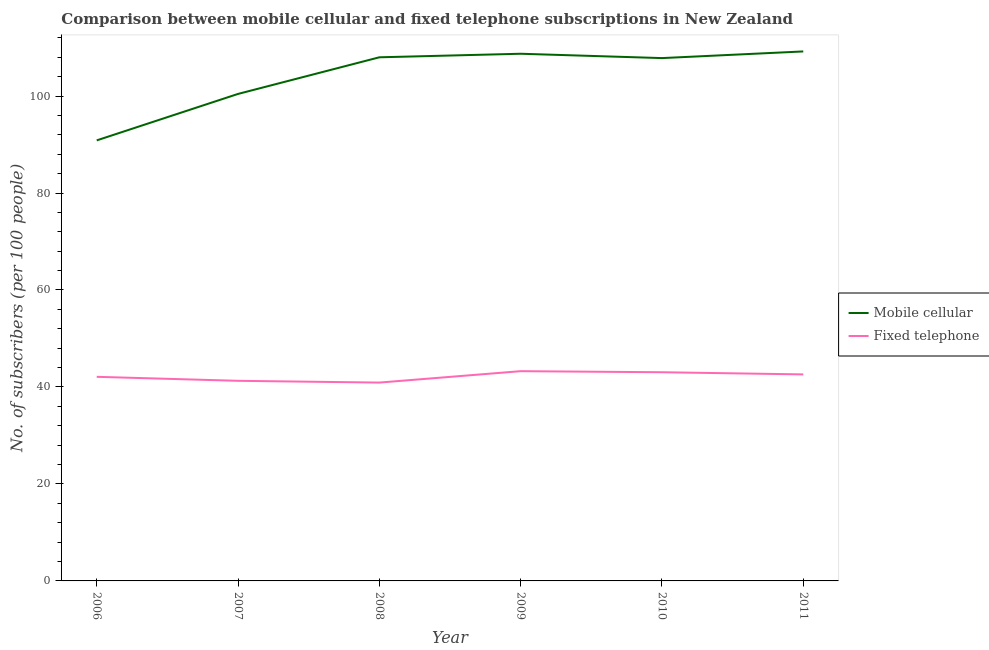How many different coloured lines are there?
Your answer should be very brief. 2. Does the line corresponding to number of fixed telephone subscribers intersect with the line corresponding to number of mobile cellular subscribers?
Your answer should be compact. No. Is the number of lines equal to the number of legend labels?
Offer a terse response. Yes. What is the number of fixed telephone subscribers in 2009?
Your answer should be compact. 43.26. Across all years, what is the maximum number of mobile cellular subscribers?
Give a very brief answer. 109.2. Across all years, what is the minimum number of mobile cellular subscribers?
Your response must be concise. 90.85. In which year was the number of mobile cellular subscribers minimum?
Provide a succinct answer. 2006. What is the total number of mobile cellular subscribers in the graph?
Your answer should be compact. 625.03. What is the difference between the number of fixed telephone subscribers in 2006 and that in 2011?
Give a very brief answer. -0.5. What is the difference between the number of fixed telephone subscribers in 2011 and the number of mobile cellular subscribers in 2009?
Ensure brevity in your answer.  -66.13. What is the average number of fixed telephone subscribers per year?
Make the answer very short. 42.19. In the year 2010, what is the difference between the number of fixed telephone subscribers and number of mobile cellular subscribers?
Make the answer very short. -64.79. In how many years, is the number of fixed telephone subscribers greater than 76?
Your answer should be compact. 0. What is the ratio of the number of fixed telephone subscribers in 2009 to that in 2010?
Your answer should be very brief. 1.01. What is the difference between the highest and the second highest number of fixed telephone subscribers?
Provide a succinct answer. 0.22. What is the difference between the highest and the lowest number of fixed telephone subscribers?
Offer a very short reply. 2.35. Is the sum of the number of mobile cellular subscribers in 2006 and 2007 greater than the maximum number of fixed telephone subscribers across all years?
Your response must be concise. Yes. Does the number of mobile cellular subscribers monotonically increase over the years?
Your response must be concise. No. How many lines are there?
Offer a very short reply. 2. Does the graph contain grids?
Your answer should be very brief. No. Where does the legend appear in the graph?
Make the answer very short. Center right. How many legend labels are there?
Your answer should be very brief. 2. What is the title of the graph?
Make the answer very short. Comparison between mobile cellular and fixed telephone subscriptions in New Zealand. Does "Rural Population" appear as one of the legend labels in the graph?
Offer a very short reply. No. What is the label or title of the X-axis?
Your answer should be very brief. Year. What is the label or title of the Y-axis?
Keep it short and to the point. No. of subscribers (per 100 people). What is the No. of subscribers (per 100 people) of Mobile cellular in 2006?
Offer a terse response. 90.85. What is the No. of subscribers (per 100 people) of Fixed telephone in 2006?
Your answer should be very brief. 42.09. What is the No. of subscribers (per 100 people) in Mobile cellular in 2007?
Provide a succinct answer. 100.44. What is the No. of subscribers (per 100 people) of Fixed telephone in 2007?
Your answer should be compact. 41.27. What is the No. of subscribers (per 100 people) in Mobile cellular in 2008?
Provide a succinct answer. 107.99. What is the No. of subscribers (per 100 people) of Fixed telephone in 2008?
Your answer should be compact. 40.91. What is the No. of subscribers (per 100 people) in Mobile cellular in 2009?
Give a very brief answer. 108.72. What is the No. of subscribers (per 100 people) of Fixed telephone in 2009?
Offer a terse response. 43.26. What is the No. of subscribers (per 100 people) in Mobile cellular in 2010?
Keep it short and to the point. 107.83. What is the No. of subscribers (per 100 people) in Fixed telephone in 2010?
Keep it short and to the point. 43.04. What is the No. of subscribers (per 100 people) of Mobile cellular in 2011?
Offer a very short reply. 109.2. What is the No. of subscribers (per 100 people) in Fixed telephone in 2011?
Provide a succinct answer. 42.59. Across all years, what is the maximum No. of subscribers (per 100 people) of Mobile cellular?
Your answer should be very brief. 109.2. Across all years, what is the maximum No. of subscribers (per 100 people) of Fixed telephone?
Your response must be concise. 43.26. Across all years, what is the minimum No. of subscribers (per 100 people) of Mobile cellular?
Ensure brevity in your answer.  90.85. Across all years, what is the minimum No. of subscribers (per 100 people) of Fixed telephone?
Offer a terse response. 40.91. What is the total No. of subscribers (per 100 people) in Mobile cellular in the graph?
Provide a short and direct response. 625.03. What is the total No. of subscribers (per 100 people) of Fixed telephone in the graph?
Keep it short and to the point. 253.16. What is the difference between the No. of subscribers (per 100 people) in Mobile cellular in 2006 and that in 2007?
Offer a very short reply. -9.58. What is the difference between the No. of subscribers (per 100 people) of Fixed telephone in 2006 and that in 2007?
Make the answer very short. 0.82. What is the difference between the No. of subscribers (per 100 people) in Mobile cellular in 2006 and that in 2008?
Give a very brief answer. -17.13. What is the difference between the No. of subscribers (per 100 people) in Fixed telephone in 2006 and that in 2008?
Your response must be concise. 1.19. What is the difference between the No. of subscribers (per 100 people) of Mobile cellular in 2006 and that in 2009?
Provide a succinct answer. -17.87. What is the difference between the No. of subscribers (per 100 people) of Fixed telephone in 2006 and that in 2009?
Give a very brief answer. -1.16. What is the difference between the No. of subscribers (per 100 people) in Mobile cellular in 2006 and that in 2010?
Keep it short and to the point. -16.97. What is the difference between the No. of subscribers (per 100 people) in Fixed telephone in 2006 and that in 2010?
Keep it short and to the point. -0.94. What is the difference between the No. of subscribers (per 100 people) in Mobile cellular in 2006 and that in 2011?
Your answer should be very brief. -18.35. What is the difference between the No. of subscribers (per 100 people) in Fixed telephone in 2006 and that in 2011?
Ensure brevity in your answer.  -0.5. What is the difference between the No. of subscribers (per 100 people) of Mobile cellular in 2007 and that in 2008?
Offer a terse response. -7.55. What is the difference between the No. of subscribers (per 100 people) of Fixed telephone in 2007 and that in 2008?
Keep it short and to the point. 0.37. What is the difference between the No. of subscribers (per 100 people) of Mobile cellular in 2007 and that in 2009?
Your answer should be very brief. -8.29. What is the difference between the No. of subscribers (per 100 people) of Fixed telephone in 2007 and that in 2009?
Make the answer very short. -1.99. What is the difference between the No. of subscribers (per 100 people) in Mobile cellular in 2007 and that in 2010?
Offer a terse response. -7.39. What is the difference between the No. of subscribers (per 100 people) of Fixed telephone in 2007 and that in 2010?
Provide a succinct answer. -1.77. What is the difference between the No. of subscribers (per 100 people) of Mobile cellular in 2007 and that in 2011?
Offer a terse response. -8.76. What is the difference between the No. of subscribers (per 100 people) of Fixed telephone in 2007 and that in 2011?
Provide a succinct answer. -1.32. What is the difference between the No. of subscribers (per 100 people) of Mobile cellular in 2008 and that in 2009?
Your answer should be compact. -0.73. What is the difference between the No. of subscribers (per 100 people) in Fixed telephone in 2008 and that in 2009?
Your response must be concise. -2.35. What is the difference between the No. of subscribers (per 100 people) in Mobile cellular in 2008 and that in 2010?
Offer a terse response. 0.16. What is the difference between the No. of subscribers (per 100 people) in Fixed telephone in 2008 and that in 2010?
Give a very brief answer. -2.13. What is the difference between the No. of subscribers (per 100 people) of Mobile cellular in 2008 and that in 2011?
Provide a short and direct response. -1.21. What is the difference between the No. of subscribers (per 100 people) in Fixed telephone in 2008 and that in 2011?
Your answer should be compact. -1.69. What is the difference between the No. of subscribers (per 100 people) in Mobile cellular in 2009 and that in 2010?
Your answer should be compact. 0.9. What is the difference between the No. of subscribers (per 100 people) of Fixed telephone in 2009 and that in 2010?
Offer a very short reply. 0.22. What is the difference between the No. of subscribers (per 100 people) of Mobile cellular in 2009 and that in 2011?
Offer a very short reply. -0.48. What is the difference between the No. of subscribers (per 100 people) in Fixed telephone in 2009 and that in 2011?
Your response must be concise. 0.67. What is the difference between the No. of subscribers (per 100 people) in Mobile cellular in 2010 and that in 2011?
Give a very brief answer. -1.37. What is the difference between the No. of subscribers (per 100 people) in Fixed telephone in 2010 and that in 2011?
Offer a very short reply. 0.45. What is the difference between the No. of subscribers (per 100 people) in Mobile cellular in 2006 and the No. of subscribers (per 100 people) in Fixed telephone in 2007?
Your answer should be very brief. 49.58. What is the difference between the No. of subscribers (per 100 people) of Mobile cellular in 2006 and the No. of subscribers (per 100 people) of Fixed telephone in 2008?
Ensure brevity in your answer.  49.95. What is the difference between the No. of subscribers (per 100 people) of Mobile cellular in 2006 and the No. of subscribers (per 100 people) of Fixed telephone in 2009?
Make the answer very short. 47.6. What is the difference between the No. of subscribers (per 100 people) in Mobile cellular in 2006 and the No. of subscribers (per 100 people) in Fixed telephone in 2010?
Offer a terse response. 47.82. What is the difference between the No. of subscribers (per 100 people) of Mobile cellular in 2006 and the No. of subscribers (per 100 people) of Fixed telephone in 2011?
Ensure brevity in your answer.  48.26. What is the difference between the No. of subscribers (per 100 people) in Mobile cellular in 2007 and the No. of subscribers (per 100 people) in Fixed telephone in 2008?
Offer a terse response. 59.53. What is the difference between the No. of subscribers (per 100 people) in Mobile cellular in 2007 and the No. of subscribers (per 100 people) in Fixed telephone in 2009?
Your response must be concise. 57.18. What is the difference between the No. of subscribers (per 100 people) in Mobile cellular in 2007 and the No. of subscribers (per 100 people) in Fixed telephone in 2010?
Make the answer very short. 57.4. What is the difference between the No. of subscribers (per 100 people) of Mobile cellular in 2007 and the No. of subscribers (per 100 people) of Fixed telephone in 2011?
Give a very brief answer. 57.84. What is the difference between the No. of subscribers (per 100 people) of Mobile cellular in 2008 and the No. of subscribers (per 100 people) of Fixed telephone in 2009?
Provide a succinct answer. 64.73. What is the difference between the No. of subscribers (per 100 people) of Mobile cellular in 2008 and the No. of subscribers (per 100 people) of Fixed telephone in 2010?
Your response must be concise. 64.95. What is the difference between the No. of subscribers (per 100 people) in Mobile cellular in 2008 and the No. of subscribers (per 100 people) in Fixed telephone in 2011?
Provide a short and direct response. 65.4. What is the difference between the No. of subscribers (per 100 people) of Mobile cellular in 2009 and the No. of subscribers (per 100 people) of Fixed telephone in 2010?
Offer a very short reply. 65.68. What is the difference between the No. of subscribers (per 100 people) of Mobile cellular in 2009 and the No. of subscribers (per 100 people) of Fixed telephone in 2011?
Give a very brief answer. 66.13. What is the difference between the No. of subscribers (per 100 people) of Mobile cellular in 2010 and the No. of subscribers (per 100 people) of Fixed telephone in 2011?
Make the answer very short. 65.23. What is the average No. of subscribers (per 100 people) in Mobile cellular per year?
Keep it short and to the point. 104.17. What is the average No. of subscribers (per 100 people) of Fixed telephone per year?
Make the answer very short. 42.19. In the year 2006, what is the difference between the No. of subscribers (per 100 people) of Mobile cellular and No. of subscribers (per 100 people) of Fixed telephone?
Ensure brevity in your answer.  48.76. In the year 2007, what is the difference between the No. of subscribers (per 100 people) of Mobile cellular and No. of subscribers (per 100 people) of Fixed telephone?
Offer a terse response. 59.17. In the year 2008, what is the difference between the No. of subscribers (per 100 people) of Mobile cellular and No. of subscribers (per 100 people) of Fixed telephone?
Keep it short and to the point. 67.08. In the year 2009, what is the difference between the No. of subscribers (per 100 people) of Mobile cellular and No. of subscribers (per 100 people) of Fixed telephone?
Offer a very short reply. 65.46. In the year 2010, what is the difference between the No. of subscribers (per 100 people) of Mobile cellular and No. of subscribers (per 100 people) of Fixed telephone?
Provide a short and direct response. 64.79. In the year 2011, what is the difference between the No. of subscribers (per 100 people) of Mobile cellular and No. of subscribers (per 100 people) of Fixed telephone?
Keep it short and to the point. 66.61. What is the ratio of the No. of subscribers (per 100 people) of Mobile cellular in 2006 to that in 2007?
Keep it short and to the point. 0.9. What is the ratio of the No. of subscribers (per 100 people) of Mobile cellular in 2006 to that in 2008?
Your answer should be very brief. 0.84. What is the ratio of the No. of subscribers (per 100 people) of Fixed telephone in 2006 to that in 2008?
Give a very brief answer. 1.03. What is the ratio of the No. of subscribers (per 100 people) of Mobile cellular in 2006 to that in 2009?
Your answer should be very brief. 0.84. What is the ratio of the No. of subscribers (per 100 people) in Fixed telephone in 2006 to that in 2009?
Make the answer very short. 0.97. What is the ratio of the No. of subscribers (per 100 people) of Mobile cellular in 2006 to that in 2010?
Offer a very short reply. 0.84. What is the ratio of the No. of subscribers (per 100 people) in Fixed telephone in 2006 to that in 2010?
Make the answer very short. 0.98. What is the ratio of the No. of subscribers (per 100 people) of Mobile cellular in 2006 to that in 2011?
Keep it short and to the point. 0.83. What is the ratio of the No. of subscribers (per 100 people) of Fixed telephone in 2006 to that in 2011?
Keep it short and to the point. 0.99. What is the ratio of the No. of subscribers (per 100 people) in Mobile cellular in 2007 to that in 2008?
Give a very brief answer. 0.93. What is the ratio of the No. of subscribers (per 100 people) in Fixed telephone in 2007 to that in 2008?
Your answer should be compact. 1.01. What is the ratio of the No. of subscribers (per 100 people) in Mobile cellular in 2007 to that in 2009?
Give a very brief answer. 0.92. What is the ratio of the No. of subscribers (per 100 people) in Fixed telephone in 2007 to that in 2009?
Ensure brevity in your answer.  0.95. What is the ratio of the No. of subscribers (per 100 people) in Mobile cellular in 2007 to that in 2010?
Offer a terse response. 0.93. What is the ratio of the No. of subscribers (per 100 people) of Fixed telephone in 2007 to that in 2010?
Offer a terse response. 0.96. What is the ratio of the No. of subscribers (per 100 people) in Mobile cellular in 2007 to that in 2011?
Make the answer very short. 0.92. What is the ratio of the No. of subscribers (per 100 people) in Fixed telephone in 2007 to that in 2011?
Offer a very short reply. 0.97. What is the ratio of the No. of subscribers (per 100 people) of Mobile cellular in 2008 to that in 2009?
Make the answer very short. 0.99. What is the ratio of the No. of subscribers (per 100 people) in Fixed telephone in 2008 to that in 2009?
Offer a very short reply. 0.95. What is the ratio of the No. of subscribers (per 100 people) of Mobile cellular in 2008 to that in 2010?
Give a very brief answer. 1. What is the ratio of the No. of subscribers (per 100 people) in Fixed telephone in 2008 to that in 2010?
Offer a very short reply. 0.95. What is the ratio of the No. of subscribers (per 100 people) in Mobile cellular in 2008 to that in 2011?
Offer a terse response. 0.99. What is the ratio of the No. of subscribers (per 100 people) in Fixed telephone in 2008 to that in 2011?
Ensure brevity in your answer.  0.96. What is the ratio of the No. of subscribers (per 100 people) in Mobile cellular in 2009 to that in 2010?
Keep it short and to the point. 1.01. What is the ratio of the No. of subscribers (per 100 people) in Mobile cellular in 2009 to that in 2011?
Offer a terse response. 1. What is the ratio of the No. of subscribers (per 100 people) of Fixed telephone in 2009 to that in 2011?
Give a very brief answer. 1.02. What is the ratio of the No. of subscribers (per 100 people) in Mobile cellular in 2010 to that in 2011?
Provide a succinct answer. 0.99. What is the ratio of the No. of subscribers (per 100 people) in Fixed telephone in 2010 to that in 2011?
Offer a terse response. 1.01. What is the difference between the highest and the second highest No. of subscribers (per 100 people) of Mobile cellular?
Provide a succinct answer. 0.48. What is the difference between the highest and the second highest No. of subscribers (per 100 people) of Fixed telephone?
Provide a short and direct response. 0.22. What is the difference between the highest and the lowest No. of subscribers (per 100 people) of Mobile cellular?
Your response must be concise. 18.35. What is the difference between the highest and the lowest No. of subscribers (per 100 people) of Fixed telephone?
Your answer should be compact. 2.35. 